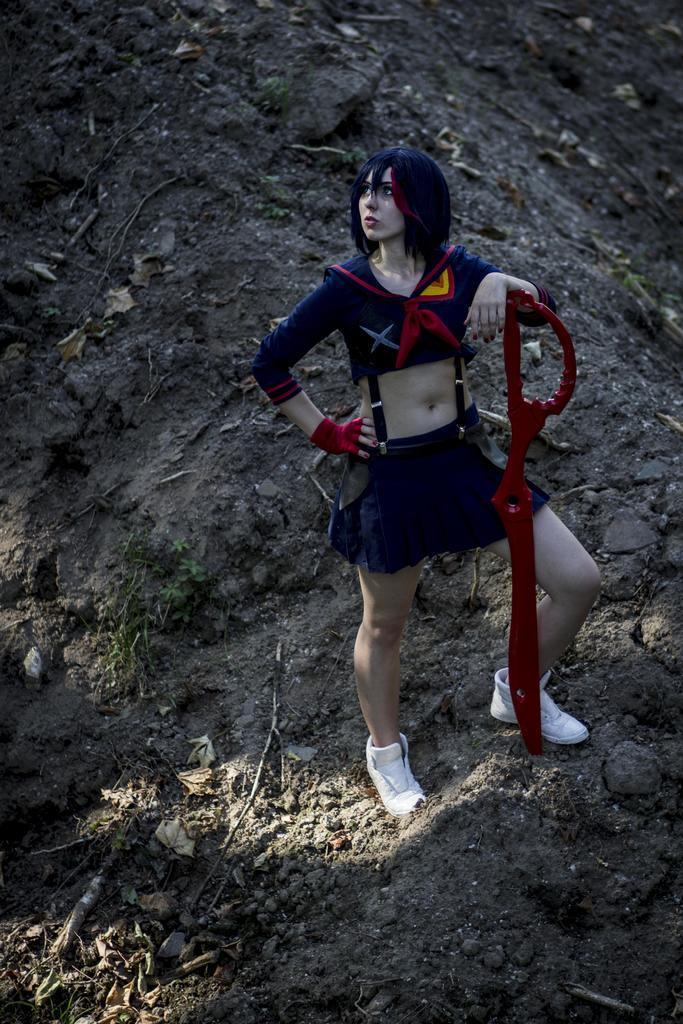Can you describe this image briefly? In the picture there is a woman standing and catching an object with the hand. 